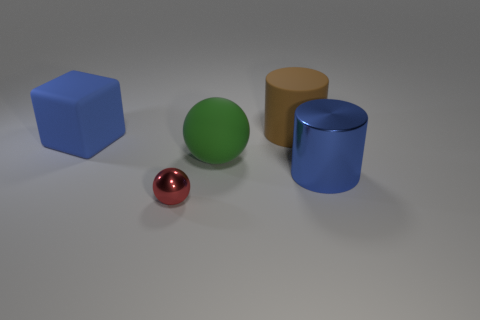Add 1 green matte things. How many objects exist? 6 Subtract all cylinders. How many objects are left? 3 Add 3 green spheres. How many green spheres are left? 4 Add 5 cylinders. How many cylinders exist? 7 Subtract 0 yellow cylinders. How many objects are left? 5 Subtract all big gray rubber blocks. Subtract all green spheres. How many objects are left? 4 